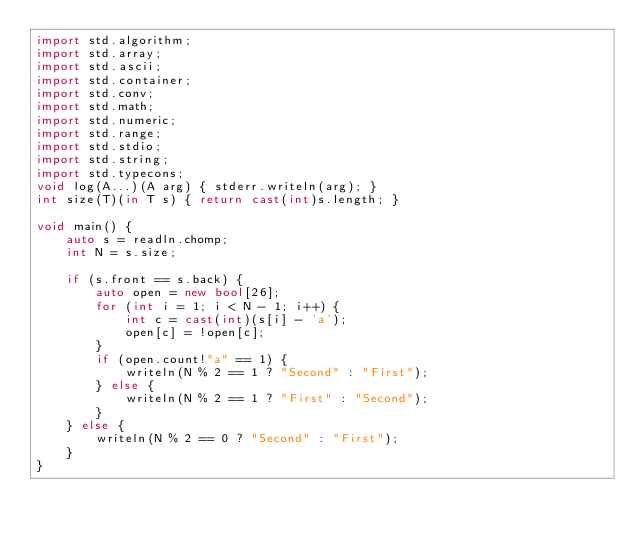<code> <loc_0><loc_0><loc_500><loc_500><_D_>import std.algorithm;
import std.array;
import std.ascii;
import std.container;
import std.conv;
import std.math;
import std.numeric;
import std.range;
import std.stdio;
import std.string;
import std.typecons;
void log(A...)(A arg) { stderr.writeln(arg); }
int size(T)(in T s) { return cast(int)s.length; }

void main() {
    auto s = readln.chomp;
    int N = s.size;

    if (s.front == s.back) {
        auto open = new bool[26];
        for (int i = 1; i < N - 1; i++) {
            int c = cast(int)(s[i] - 'a');
            open[c] = !open[c];
        }
        if (open.count!"a" == 1) {
            writeln(N % 2 == 1 ? "Second" : "First");
        } else {
            writeln(N % 2 == 1 ? "First" : "Second");
        }
    } else {
        writeln(N % 2 == 0 ? "Second" : "First");
    }
}
</code> 